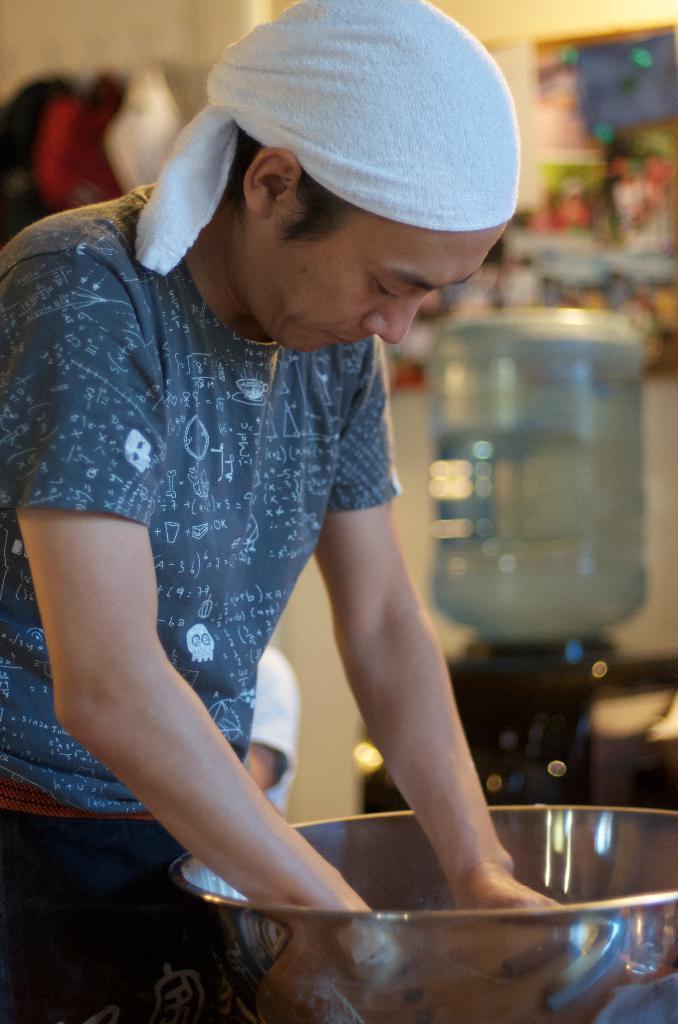Can you describe this image briefly? The picture consists of a person standing, wearing a blue t-shirt, in front of him there is a bowl. In the background there are posters, cloth, person, water bubble, wall and other objects. 